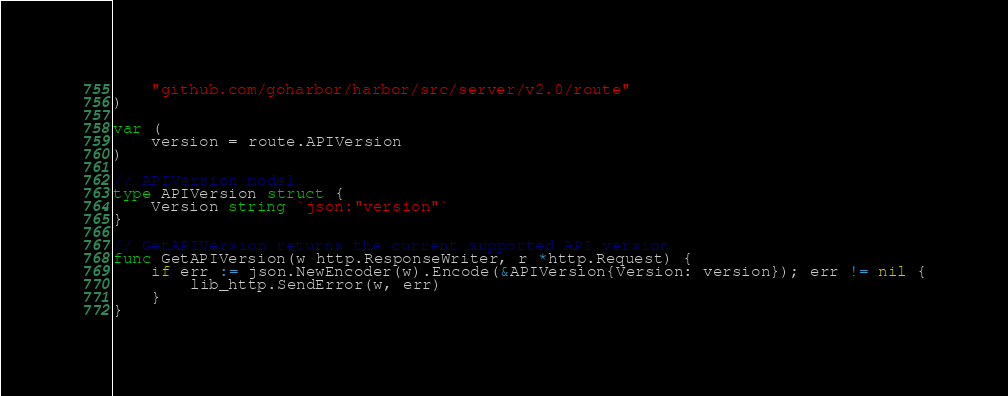Convert code to text. <code><loc_0><loc_0><loc_500><loc_500><_Go_>
	"github.com/goharbor/harbor/src/server/v2.0/route"
)

var (
	version = route.APIVersion
)

// APIVersion model
type APIVersion struct {
	Version string `json:"version"`
}

// GetAPIVersion returns the current supported API version
func GetAPIVersion(w http.ResponseWriter, r *http.Request) {
	if err := json.NewEncoder(w).Encode(&APIVersion{Version: version}); err != nil {
		lib_http.SendError(w, err)
	}
}
</code> 